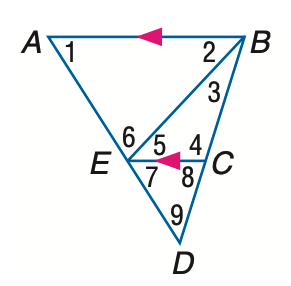Answer the mathemtical geometry problem and directly provide the correct option letter.
Question: In the figure, m \angle 1 = 58, m \angle 2 = 47, and m \angle 3 = 26. Find the measure of \angle 8.
Choices: A: 65 B: 73 C: 75 D: 83 B 